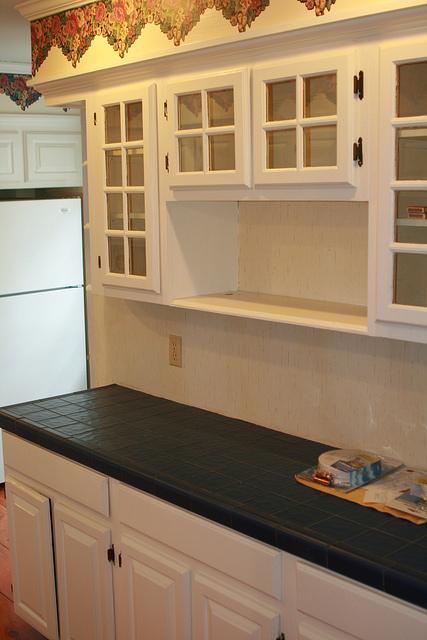What color is the table top?
Keep it brief. Black. Are the kitchen cabinets empty?
Give a very brief answer. Yes. Is this kitchen well stocked?
Concise answer only. No. 